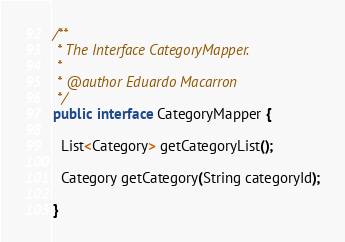<code> <loc_0><loc_0><loc_500><loc_500><_Java_>/**
 * The Interface CategoryMapper.
 *
 * @author Eduardo Macarron
 */
public interface CategoryMapper {

  List<Category> getCategoryList();

  Category getCategory(String categoryId);

}
</code> 